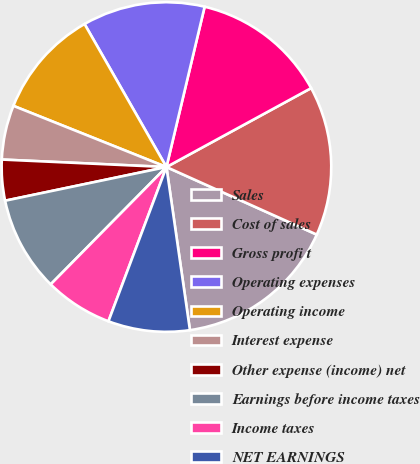Convert chart to OTSL. <chart><loc_0><loc_0><loc_500><loc_500><pie_chart><fcel>Sales<fcel>Cost of sales<fcel>Gross profi t<fcel>Operating expenses<fcel>Operating income<fcel>Interest expense<fcel>Other expense (income) net<fcel>Earnings before income taxes<fcel>Income taxes<fcel>NET EARNINGS<nl><fcel>16.0%<fcel>14.67%<fcel>13.33%<fcel>12.0%<fcel>10.67%<fcel>5.33%<fcel>4.0%<fcel>9.33%<fcel>6.67%<fcel>8.0%<nl></chart> 